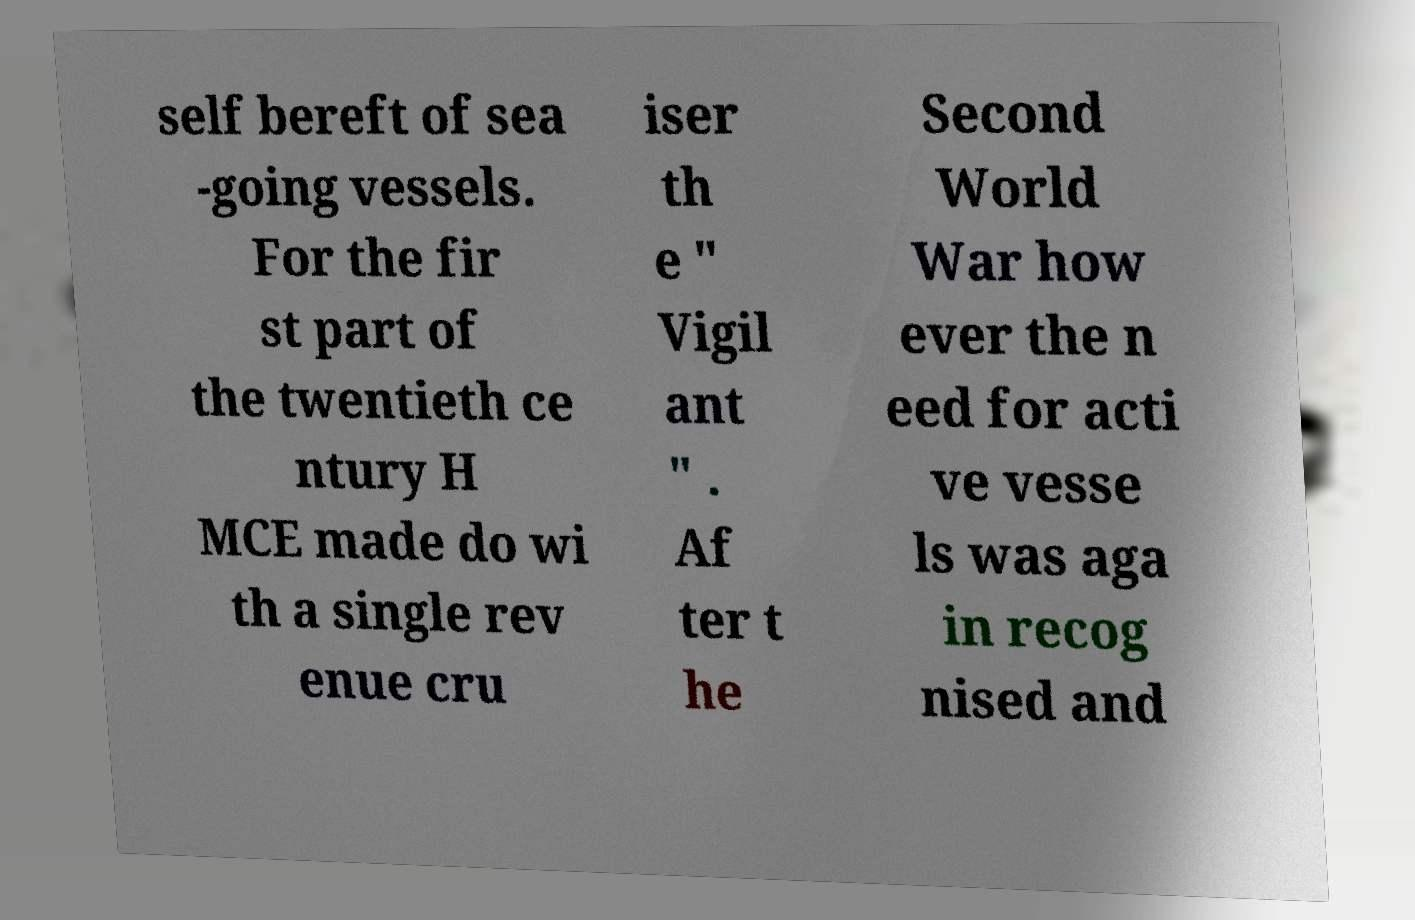Please read and relay the text visible in this image. What does it say? self bereft of sea -going vessels. For the fir st part of the twentieth ce ntury H MCE made do wi th a single rev enue cru iser th e " Vigil ant " . Af ter t he Second World War how ever the n eed for acti ve vesse ls was aga in recog nised and 